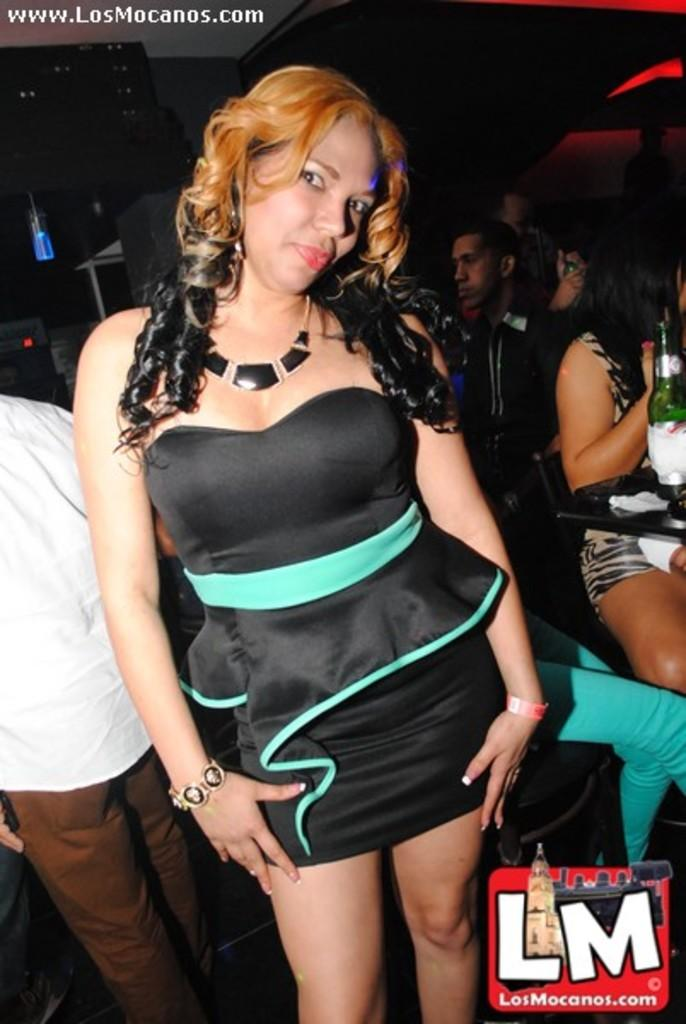<image>
Share a concise interpretation of the image provided. A woman in a blue and black dress with the caption LM at the bottom. 